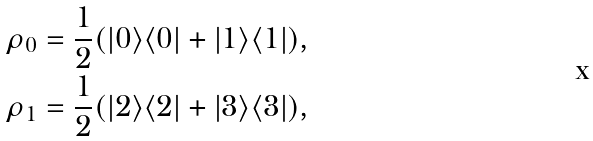Convert formula to latex. <formula><loc_0><loc_0><loc_500><loc_500>\rho _ { 0 } = \frac { 1 } 2 ( | 0 \rangle \langle 0 | + | 1 \rangle \langle 1 | ) , \\ \rho _ { 1 } = \frac { 1 } 2 ( | 2 \rangle \langle 2 | + | 3 \rangle \langle 3 | ) ,</formula> 